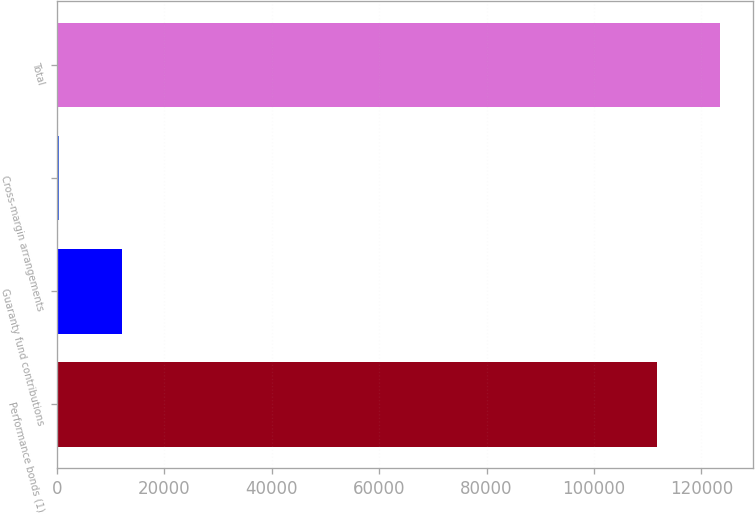Convert chart. <chart><loc_0><loc_0><loc_500><loc_500><bar_chart><fcel>Performance bonds (1)<fcel>Guaranty fund contributions<fcel>Cross-margin arrangements<fcel>Total<nl><fcel>111764<fcel>12052.4<fcel>351.3<fcel>123465<nl></chart> 